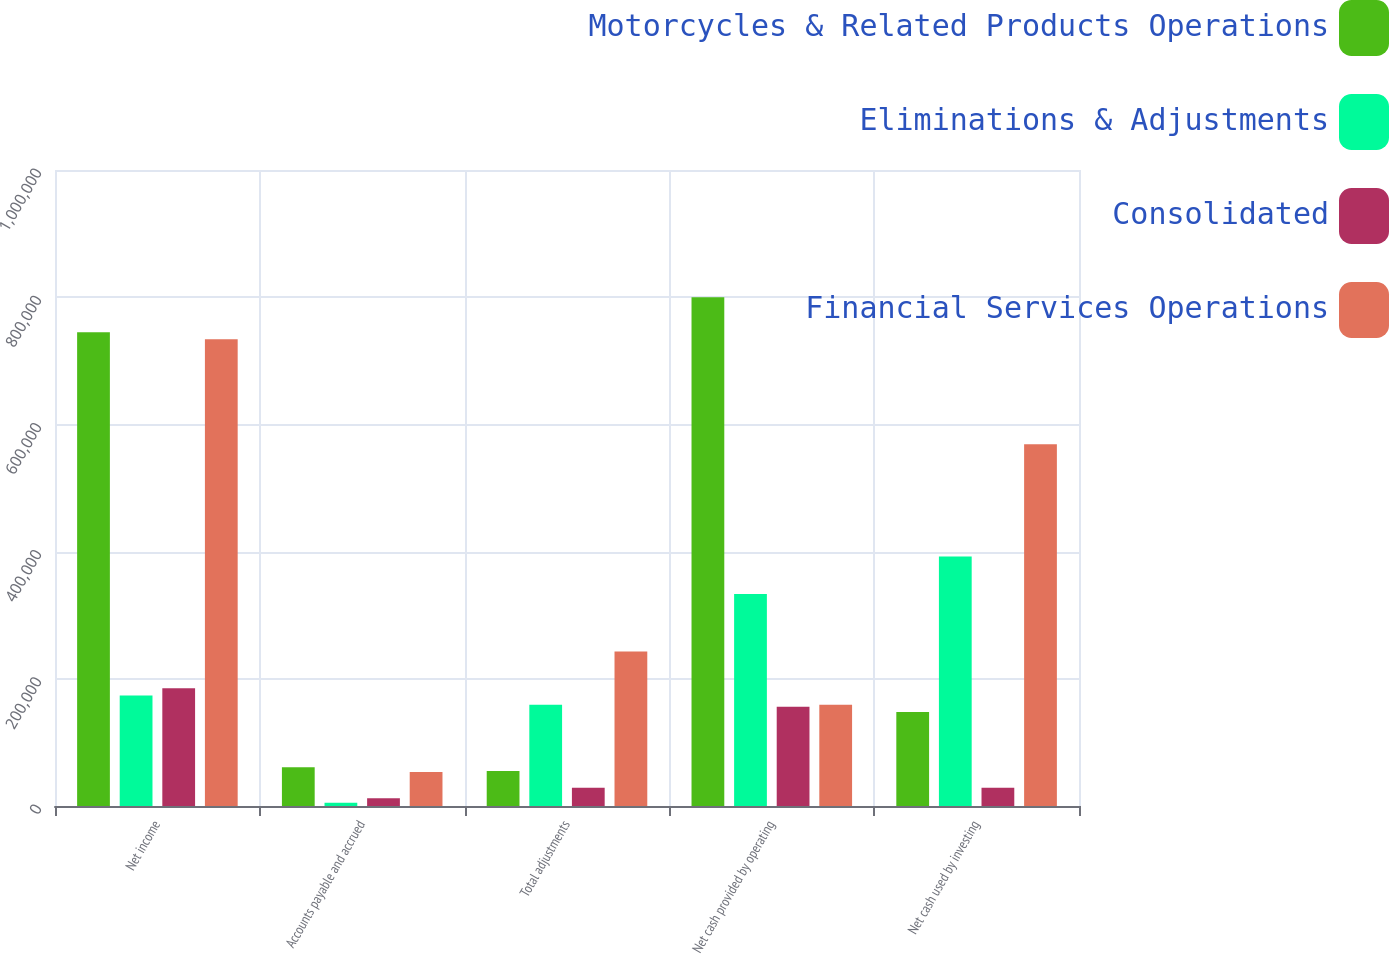Convert chart. <chart><loc_0><loc_0><loc_500><loc_500><stacked_bar_chart><ecel><fcel>Net income<fcel>Accounts payable and accrued<fcel>Total adjustments<fcel>Net cash provided by operating<fcel>Net cash used by investing<nl><fcel>Motorcycles & Related Products Operations<fcel>745077<fcel>60907<fcel>54924<fcel>800001<fcel>147889<nl><fcel>Eliminations & Adjustments<fcel>173916<fcel>5096<fcel>159311<fcel>333227<fcel>392113<nl><fcel>Consolidated<fcel>185000<fcel>12380<fcel>28865<fcel>156135<fcel>28865<nl><fcel>Financial Services Operations<fcel>733993<fcel>53623<fcel>243100<fcel>159311<fcel>568867<nl></chart> 